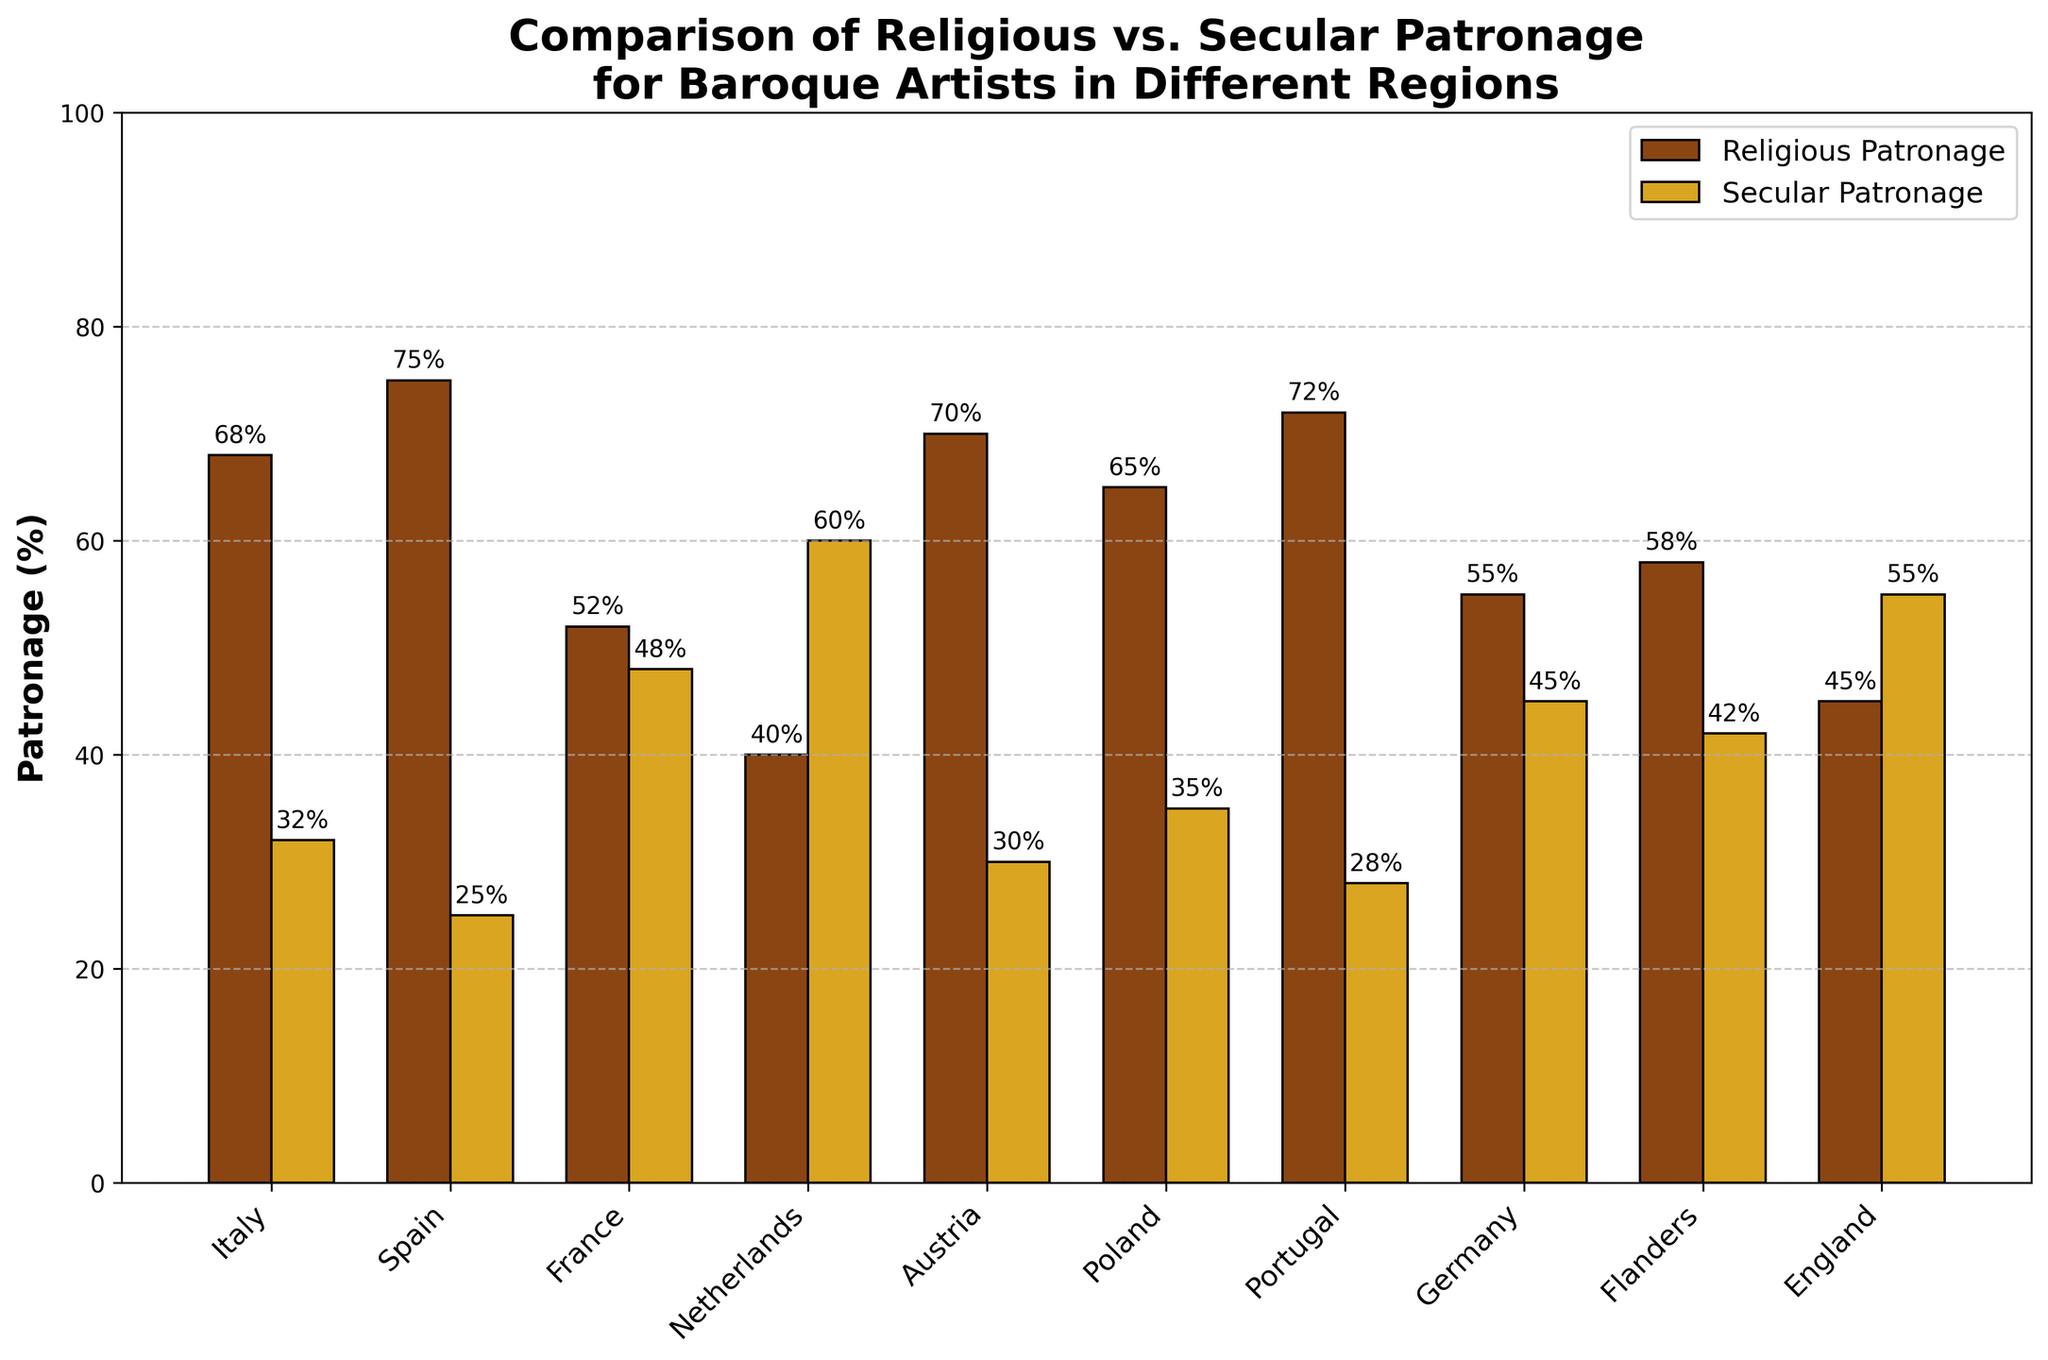What region has the highest percentage of religious patronage? Looking at the chart, Spain has the tallest brown-colored bar indicating the highest percentage of religious patronage at 75%.
Answer: Spain Which region has a greater percentage of secular patronage, Netherlands or France? The golden-colored bar for secular patronage in the Netherlands is taller than the one for France, indicating 60% for the Netherlands compared to 48% for France.
Answer: Netherlands What is the difference in religious patronage between Italy and Austria? The brown-colored bar for Italy shows 68% and for Austria shows 70%. The difference is 70% - 68% = 2%.
Answer: 2% What is the average percentage of religious patronage across all regions? Sum the percentages of religious patronage for all regions and then divide by the number of regions: (68 + 75 + 52 + 40 + 70 + 65 + 72 + 55 + 58 + 45)/10 = 600/10 = 60%.
Answer: 60% Which region has the smallest difference between religious and secular patronage percentages? Examine the bars for each region and compare the differences. France shows the smallest difference since its bars for religious (52%) and secular (48%) are the closest, with a difference of 4%.
Answer: France How much higher is the percentage of secular patronage in England compared to Spain? The golden-colored bar for secular patronage in England is 55%, and in Spain, it is 25%. The difference is 55% - 25% = 30%.
Answer: 30% Which two regions have the most similar percentages of religious patronage? The brown-colored bars for religious patronage in Italy (68%) and Poland (65%) are close to each other, with a difference of only 3%.
Answer: Italy and Poland What is the total percentage of secular patronage in France, Germany, and Flanders combined? Add the golden-colored bars for secular patronage for these regions: 48% (France) + 45% (Germany) + 42% (Flanders) = 135%.
Answer: 135% Which region’s religious patronage is closer to the average religious patronage across all regions? Average religious patronage is 60%. The region closest to this is Germany with 55%, followed by Flanders with 58%.
Answer: Flanders 